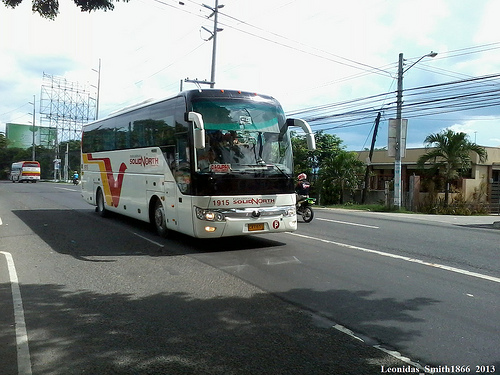Create a short realistic conversation between two friends seeing the bus passing by. Friend 1: "Hey look, isn't that the bus we used to take to school?"
Friend 2: "Yeah, it sure is! Brings back memories, doesn't it?"
Friend 1: "I remember always trying to get the window seat."
Friend 2: "Haha, and you always managed to get it!" 